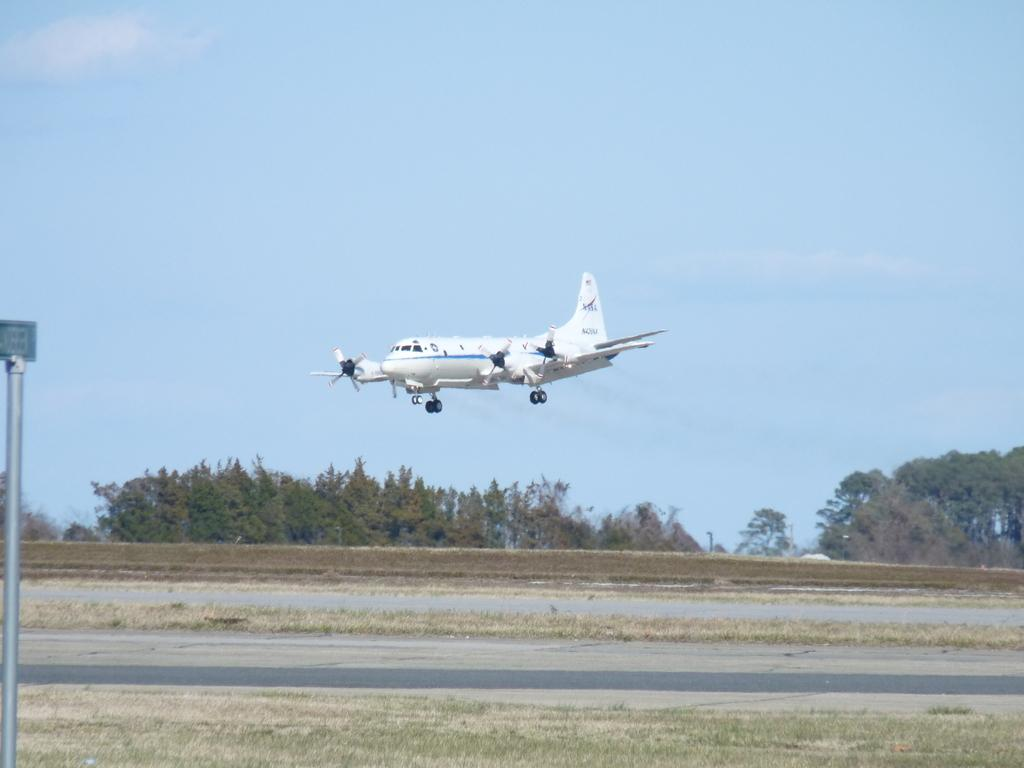What is the main subject in the sky in the image? There is an airplane in the sky in the image. What object can be seen near the ground in the image? There is a name board in the image. What type of natural vegetation is present in the image? There are trees in the image. What is visible at the bottom of the image? The ground is visible at the bottom of the image. What type of man-made structure can be seen in the image? There is a road in the image. Can you hear the doll sneezing in the image? There is no doll present in the image, and therefore no sneezing can be heard. 